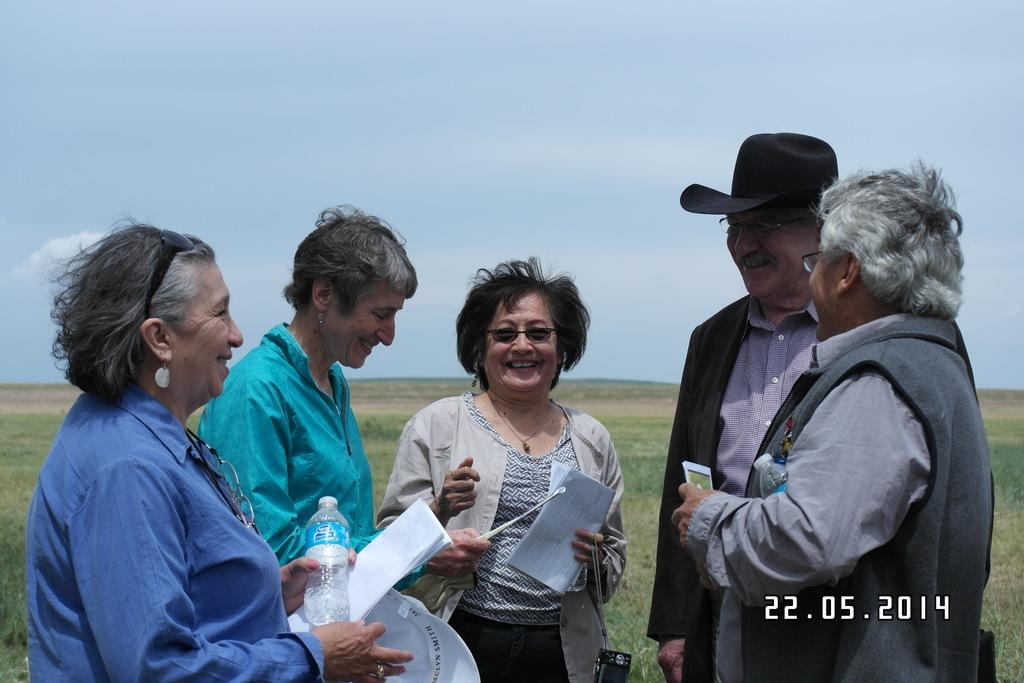What are the people in the center of the image doing? The persons in the center of the image are standing and holding papers. What can be seen in the background of the image? There is grass, plants, and the sky visible in the background of the image. What is the condition of the sky in the image? The sky is visible in the background of the image, and clouds are present. How many limits can be seen in the image? There are no limits present in the image. What type of bee can be seen buzzing around the plants in the image? There are no bees present in the image; only plants and the sky are visible in the background. 